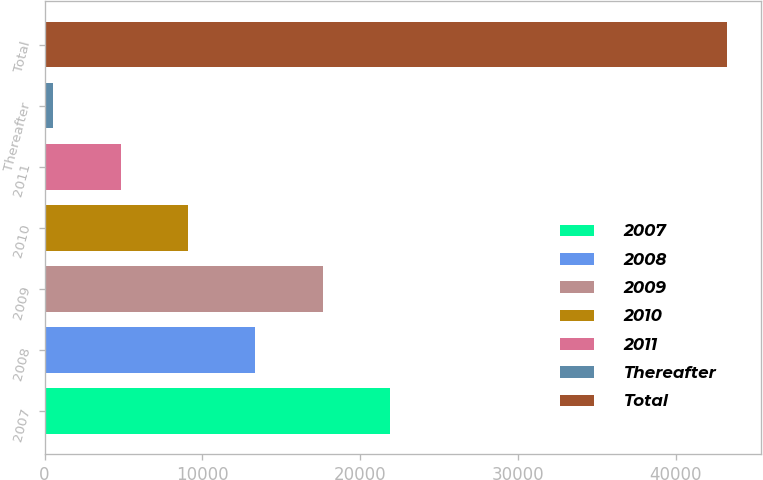Convert chart. <chart><loc_0><loc_0><loc_500><loc_500><bar_chart><fcel>2007<fcel>2008<fcel>2009<fcel>2010<fcel>2011<fcel>Thereafter<fcel>Total<nl><fcel>21902.5<fcel>13364.3<fcel>17633.4<fcel>9095.2<fcel>4826.1<fcel>557<fcel>43248<nl></chart> 